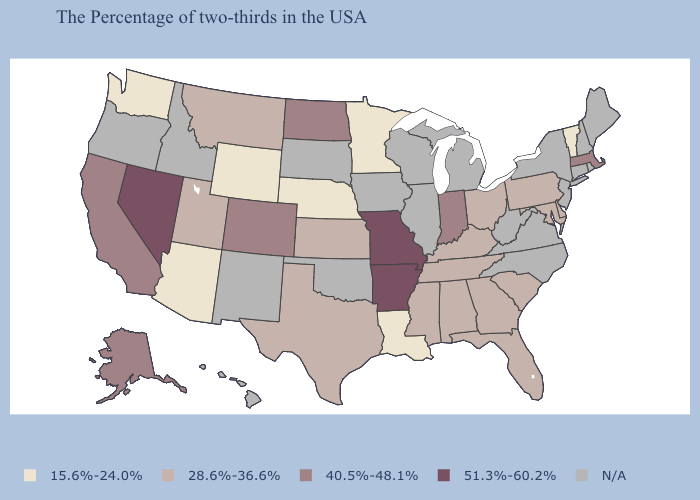Name the states that have a value in the range 40.5%-48.1%?
Concise answer only. Massachusetts, Indiana, North Dakota, Colorado, California, Alaska. What is the lowest value in the South?
Short answer required. 15.6%-24.0%. Which states have the lowest value in the USA?
Quick response, please. Vermont, Louisiana, Minnesota, Nebraska, Wyoming, Arizona, Washington. What is the value of Idaho?
Be succinct. N/A. What is the value of Ohio?
Short answer required. 28.6%-36.6%. Name the states that have a value in the range 15.6%-24.0%?
Give a very brief answer. Vermont, Louisiana, Minnesota, Nebraska, Wyoming, Arizona, Washington. Name the states that have a value in the range 51.3%-60.2%?
Be succinct. Missouri, Arkansas, Nevada. What is the value of Oregon?
Quick response, please. N/A. Which states have the highest value in the USA?
Write a very short answer. Missouri, Arkansas, Nevada. Name the states that have a value in the range 15.6%-24.0%?
Write a very short answer. Vermont, Louisiana, Minnesota, Nebraska, Wyoming, Arizona, Washington. Name the states that have a value in the range 40.5%-48.1%?
Short answer required. Massachusetts, Indiana, North Dakota, Colorado, California, Alaska. What is the value of Washington?
Answer briefly. 15.6%-24.0%. Name the states that have a value in the range 40.5%-48.1%?
Quick response, please. Massachusetts, Indiana, North Dakota, Colorado, California, Alaska. Name the states that have a value in the range 15.6%-24.0%?
Quick response, please. Vermont, Louisiana, Minnesota, Nebraska, Wyoming, Arizona, Washington. What is the value of Iowa?
Answer briefly. N/A. 